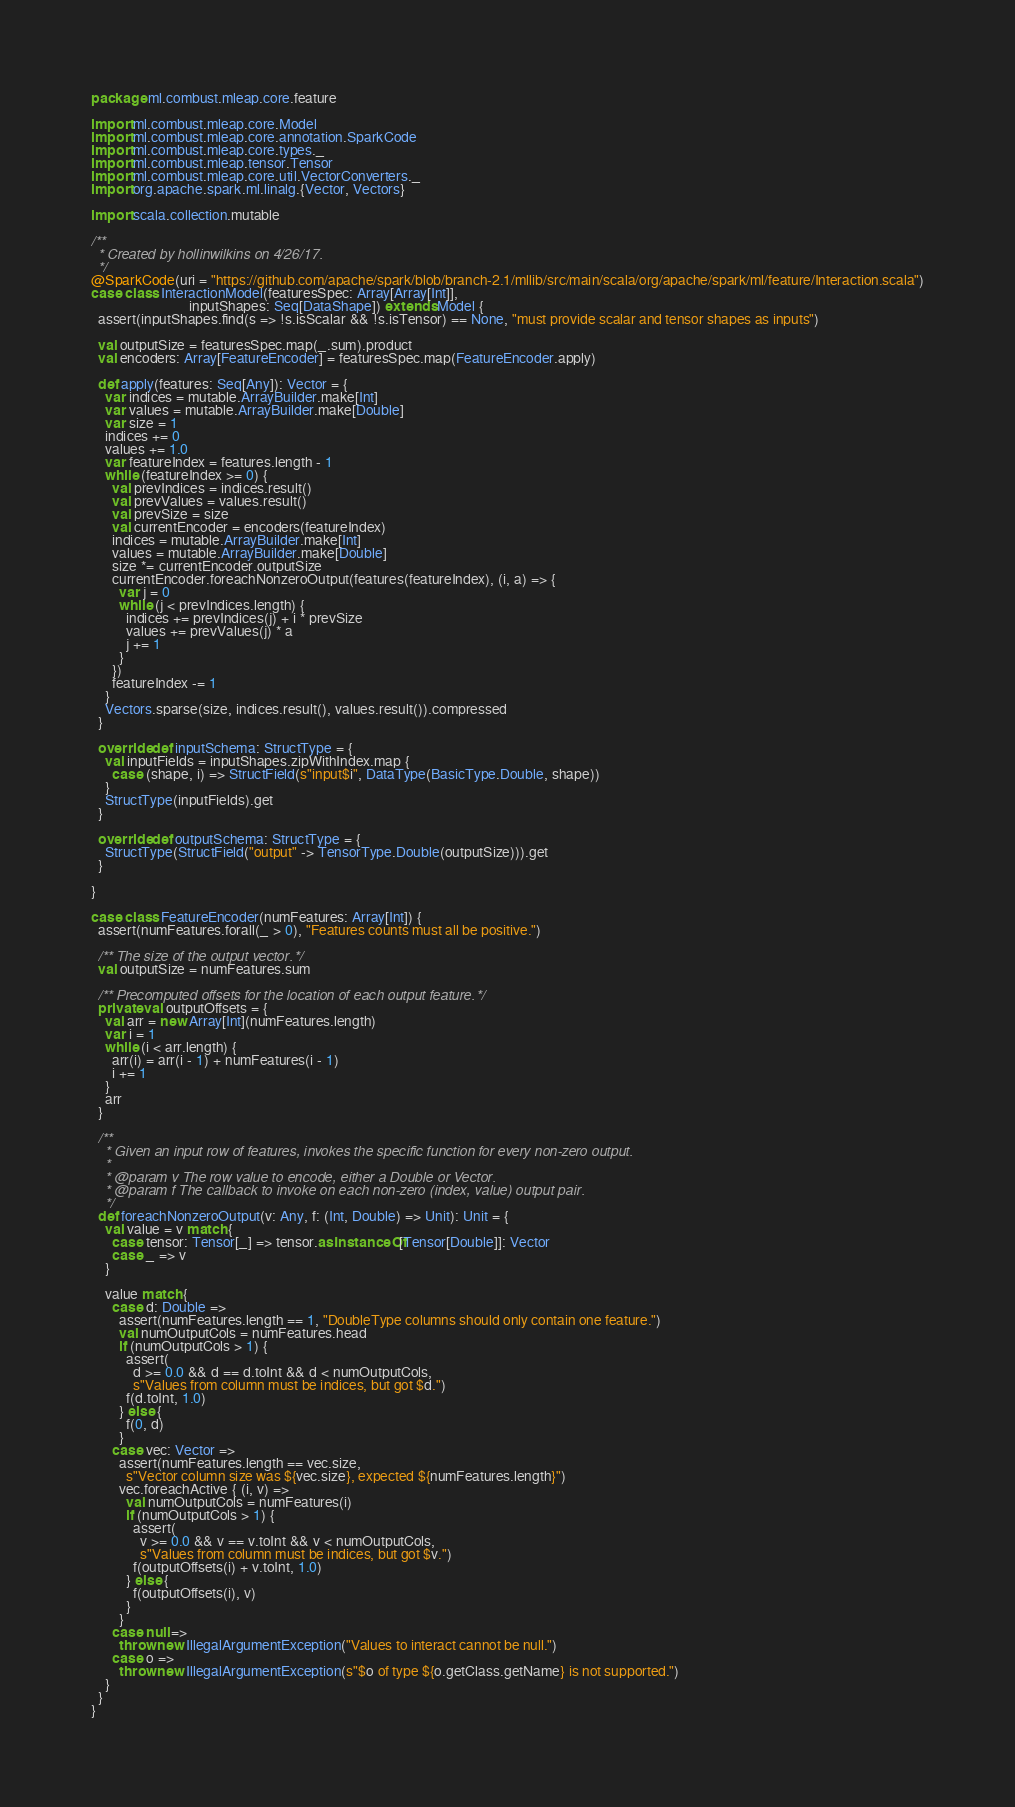Convert code to text. <code><loc_0><loc_0><loc_500><loc_500><_Scala_>package ml.combust.mleap.core.feature

import ml.combust.mleap.core.Model
import ml.combust.mleap.core.annotation.SparkCode
import ml.combust.mleap.core.types._
import ml.combust.mleap.tensor.Tensor
import ml.combust.mleap.core.util.VectorConverters._
import org.apache.spark.ml.linalg.{Vector, Vectors}

import scala.collection.mutable

/**
  * Created by hollinwilkins on 4/26/17.
  */
@SparkCode(uri = "https://github.com/apache/spark/blob/branch-2.1/mllib/src/main/scala/org/apache/spark/ml/feature/Interaction.scala")
case class InteractionModel(featuresSpec: Array[Array[Int]],
                            inputShapes: Seq[DataShape]) extends Model {
  assert(inputShapes.find(s => !s.isScalar && !s.isTensor) == None, "must provide scalar and tensor shapes as inputs")

  val outputSize = featuresSpec.map(_.sum).product
  val encoders: Array[FeatureEncoder] = featuresSpec.map(FeatureEncoder.apply)

  def apply(features: Seq[Any]): Vector = {
    var indices = mutable.ArrayBuilder.make[Int]
    var values = mutable.ArrayBuilder.make[Double]
    var size = 1
    indices += 0
    values += 1.0
    var featureIndex = features.length - 1
    while (featureIndex >= 0) {
      val prevIndices = indices.result()
      val prevValues = values.result()
      val prevSize = size
      val currentEncoder = encoders(featureIndex)
      indices = mutable.ArrayBuilder.make[Int]
      values = mutable.ArrayBuilder.make[Double]
      size *= currentEncoder.outputSize
      currentEncoder.foreachNonzeroOutput(features(featureIndex), (i, a) => {
        var j = 0
        while (j < prevIndices.length) {
          indices += prevIndices(j) + i * prevSize
          values += prevValues(j) * a
          j += 1
        }
      })
      featureIndex -= 1
    }
    Vectors.sparse(size, indices.result(), values.result()).compressed
  }

  override def inputSchema: StructType = {
    val inputFields = inputShapes.zipWithIndex.map {
      case (shape, i) => StructField(s"input$i", DataType(BasicType.Double, shape))
    }
    StructType(inputFields).get
  }

  override def outputSchema: StructType = {
    StructType(StructField("output" -> TensorType.Double(outputSize))).get
  }

}

case class FeatureEncoder(numFeatures: Array[Int]) {
  assert(numFeatures.forall(_ > 0), "Features counts must all be positive.")

  /** The size of the output vector. */
  val outputSize = numFeatures.sum

  /** Precomputed offsets for the location of each output feature. */
  private val outputOffsets = {
    val arr = new Array[Int](numFeatures.length)
    var i = 1
    while (i < arr.length) {
      arr(i) = arr(i - 1) + numFeatures(i - 1)
      i += 1
    }
    arr
  }

  /**
    * Given an input row of features, invokes the specific function for every non-zero output.
    *
    * @param v The row value to encode, either a Double or Vector.
    * @param f The callback to invoke on each non-zero (index, value) output pair.
    */
  def foreachNonzeroOutput(v: Any, f: (Int, Double) => Unit): Unit = {
    val value = v match {
      case tensor: Tensor[_] => tensor.asInstanceOf[Tensor[Double]]: Vector
      case _ => v
    }

    value match {
      case d: Double =>
        assert(numFeatures.length == 1, "DoubleType columns should only contain one feature.")
        val numOutputCols = numFeatures.head
        if (numOutputCols > 1) {
          assert(
            d >= 0.0 && d == d.toInt && d < numOutputCols,
            s"Values from column must be indices, but got $d.")
          f(d.toInt, 1.0)
        } else {
          f(0, d)
        }
      case vec: Vector =>
        assert(numFeatures.length == vec.size,
          s"Vector column size was ${vec.size}, expected ${numFeatures.length}")
        vec.foreachActive { (i, v) =>
          val numOutputCols = numFeatures(i)
          if (numOutputCols > 1) {
            assert(
              v >= 0.0 && v == v.toInt && v < numOutputCols,
              s"Values from column must be indices, but got $v.")
            f(outputOffsets(i) + v.toInt, 1.0)
          } else {
            f(outputOffsets(i), v)
          }
        }
      case null =>
        throw new IllegalArgumentException("Values to interact cannot be null.")
      case o =>
        throw new IllegalArgumentException(s"$o of type ${o.getClass.getName} is not supported.")
    }
  }
}
</code> 